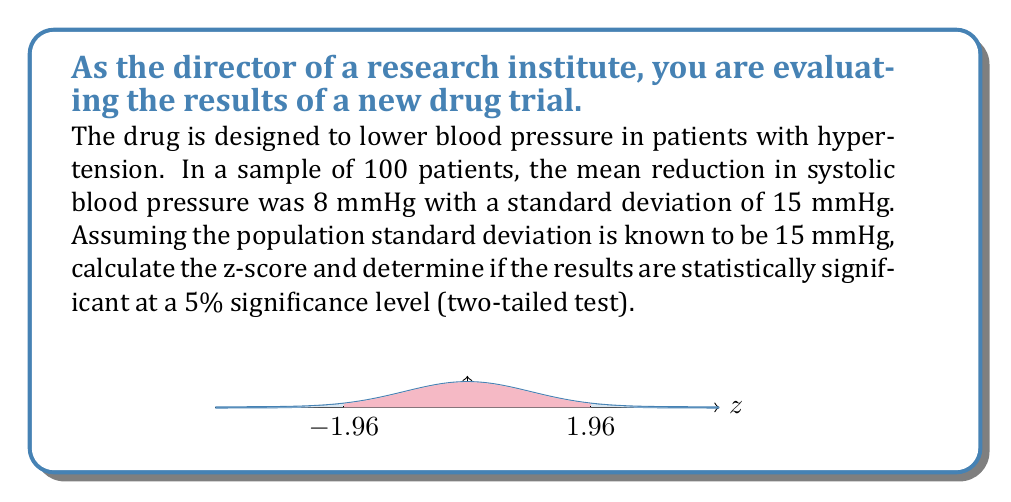Can you solve this math problem? Let's approach this step-by-step:

1) First, we need to calculate the z-score. The formula for z-score is:

   $$ z = \frac{\bar{x} - \mu}{\sigma / \sqrt{n}} $$

   Where:
   $\bar{x}$ is the sample mean
   $\mu$ is the population mean (in this case, 0, as we're testing if there's a significant difference from no effect)
   $\sigma$ is the population standard deviation
   $n$ is the sample size

2) We have:
   $\bar{x} = 8$ mmHg
   $\mu = 0$ mmHg (null hypothesis)
   $\sigma = 15$ mmHg
   $n = 100$

3) Plugging these values into the formula:

   $$ z = \frac{8 - 0}{15 / \sqrt{100}} = \frac{8}{15/10} = \frac{8}{1.5} = 5.33 $$

4) For a two-tailed test at 5% significance level, the critical z-values are ±1.96. If our calculated z-score falls outside this range, we reject the null hypothesis.

5) Our z-score of 5.33 is greater than 1.96, so we reject the null hypothesis.

6) This means the results are statistically significant at the 5% level.
Answer: $z = 5.33$; statistically significant 